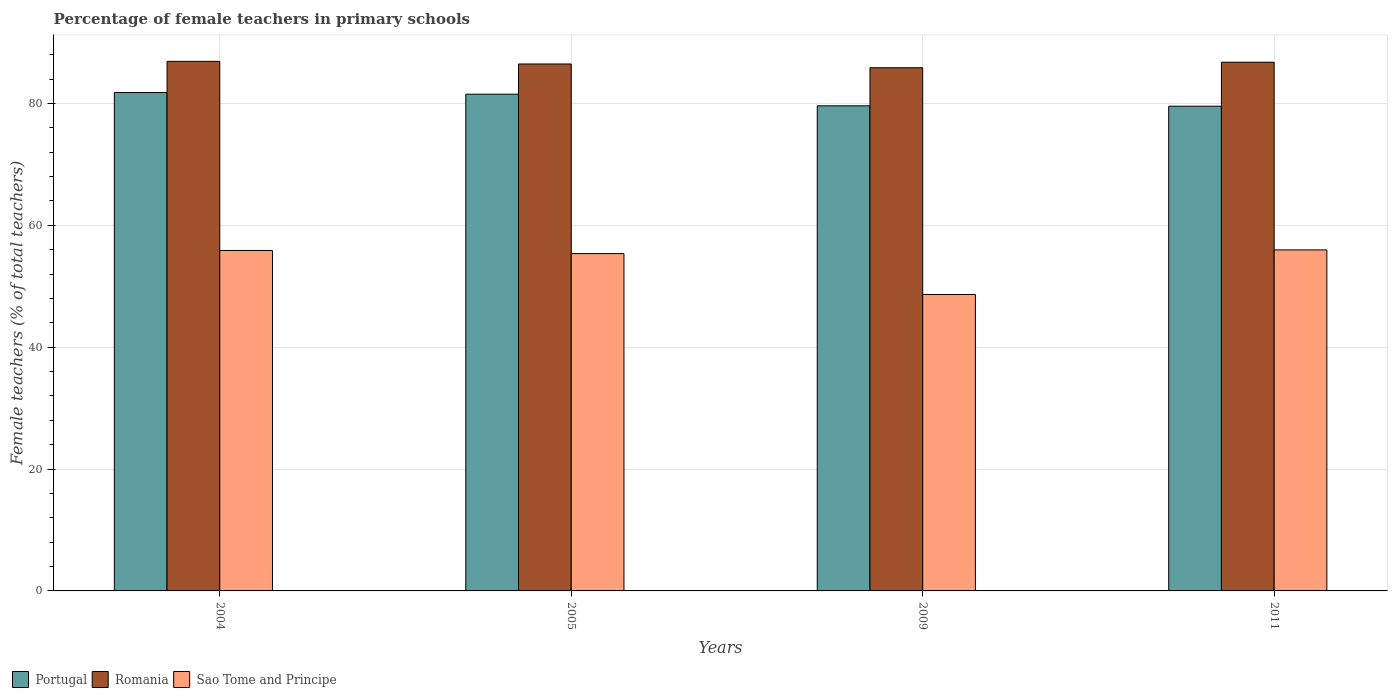Are the number of bars per tick equal to the number of legend labels?
Make the answer very short. Yes. How many bars are there on the 1st tick from the right?
Keep it short and to the point. 3. In how many cases, is the number of bars for a given year not equal to the number of legend labels?
Give a very brief answer. 0. What is the percentage of female teachers in Portugal in 2009?
Provide a succinct answer. 79.6. Across all years, what is the maximum percentage of female teachers in Romania?
Your answer should be very brief. 86.9. Across all years, what is the minimum percentage of female teachers in Romania?
Make the answer very short. 85.85. In which year was the percentage of female teachers in Romania maximum?
Your answer should be compact. 2004. What is the total percentage of female teachers in Portugal in the graph?
Keep it short and to the point. 322.45. What is the difference between the percentage of female teachers in Romania in 2005 and that in 2009?
Provide a short and direct response. 0.62. What is the difference between the percentage of female teachers in Romania in 2009 and the percentage of female teachers in Portugal in 2004?
Keep it short and to the point. 4.06. What is the average percentage of female teachers in Portugal per year?
Make the answer very short. 80.61. In the year 2005, what is the difference between the percentage of female teachers in Sao Tome and Principe and percentage of female teachers in Romania?
Provide a short and direct response. -31.12. What is the ratio of the percentage of female teachers in Romania in 2005 to that in 2009?
Make the answer very short. 1.01. Is the difference between the percentage of female teachers in Sao Tome and Principe in 2004 and 2005 greater than the difference between the percentage of female teachers in Romania in 2004 and 2005?
Provide a short and direct response. Yes. What is the difference between the highest and the second highest percentage of female teachers in Portugal?
Keep it short and to the point. 0.27. What is the difference between the highest and the lowest percentage of female teachers in Sao Tome and Principe?
Keep it short and to the point. 7.31. In how many years, is the percentage of female teachers in Romania greater than the average percentage of female teachers in Romania taken over all years?
Provide a succinct answer. 2. Is the sum of the percentage of female teachers in Sao Tome and Principe in 2004 and 2005 greater than the maximum percentage of female teachers in Portugal across all years?
Offer a terse response. Yes. Is it the case that in every year, the sum of the percentage of female teachers in Portugal and percentage of female teachers in Romania is greater than the percentage of female teachers in Sao Tome and Principe?
Give a very brief answer. Yes. How many years are there in the graph?
Your response must be concise. 4. What is the difference between two consecutive major ticks on the Y-axis?
Your answer should be very brief. 20. Does the graph contain grids?
Make the answer very short. Yes. How many legend labels are there?
Ensure brevity in your answer.  3. What is the title of the graph?
Your response must be concise. Percentage of female teachers in primary schools. Does "Tanzania" appear as one of the legend labels in the graph?
Your response must be concise. No. What is the label or title of the Y-axis?
Provide a short and direct response. Female teachers (% of total teachers). What is the Female teachers (% of total teachers) of Portugal in 2004?
Offer a terse response. 81.79. What is the Female teachers (% of total teachers) of Romania in 2004?
Offer a terse response. 86.9. What is the Female teachers (% of total teachers) of Sao Tome and Principe in 2004?
Provide a succinct answer. 55.87. What is the Female teachers (% of total teachers) of Portugal in 2005?
Keep it short and to the point. 81.52. What is the Female teachers (% of total teachers) in Romania in 2005?
Your response must be concise. 86.47. What is the Female teachers (% of total teachers) in Sao Tome and Principe in 2005?
Provide a succinct answer. 55.35. What is the Female teachers (% of total teachers) of Portugal in 2009?
Offer a very short reply. 79.6. What is the Female teachers (% of total teachers) of Romania in 2009?
Offer a very short reply. 85.85. What is the Female teachers (% of total teachers) of Sao Tome and Principe in 2009?
Provide a succinct answer. 48.64. What is the Female teachers (% of total teachers) of Portugal in 2011?
Your answer should be compact. 79.54. What is the Female teachers (% of total teachers) in Romania in 2011?
Your response must be concise. 86.76. What is the Female teachers (% of total teachers) of Sao Tome and Principe in 2011?
Provide a succinct answer. 55.96. Across all years, what is the maximum Female teachers (% of total teachers) of Portugal?
Give a very brief answer. 81.79. Across all years, what is the maximum Female teachers (% of total teachers) in Romania?
Keep it short and to the point. 86.9. Across all years, what is the maximum Female teachers (% of total teachers) in Sao Tome and Principe?
Give a very brief answer. 55.96. Across all years, what is the minimum Female teachers (% of total teachers) of Portugal?
Your answer should be compact. 79.54. Across all years, what is the minimum Female teachers (% of total teachers) in Romania?
Provide a short and direct response. 85.85. Across all years, what is the minimum Female teachers (% of total teachers) of Sao Tome and Principe?
Offer a very short reply. 48.64. What is the total Female teachers (% of total teachers) of Portugal in the graph?
Provide a short and direct response. 322.45. What is the total Female teachers (% of total teachers) in Romania in the graph?
Offer a terse response. 345.99. What is the total Female teachers (% of total teachers) of Sao Tome and Principe in the graph?
Your response must be concise. 215.82. What is the difference between the Female teachers (% of total teachers) of Portugal in 2004 and that in 2005?
Give a very brief answer. 0.27. What is the difference between the Female teachers (% of total teachers) in Romania in 2004 and that in 2005?
Make the answer very short. 0.43. What is the difference between the Female teachers (% of total teachers) of Sao Tome and Principe in 2004 and that in 2005?
Your response must be concise. 0.51. What is the difference between the Female teachers (% of total teachers) of Portugal in 2004 and that in 2009?
Keep it short and to the point. 2.18. What is the difference between the Female teachers (% of total teachers) of Romania in 2004 and that in 2009?
Ensure brevity in your answer.  1.05. What is the difference between the Female teachers (% of total teachers) in Sao Tome and Principe in 2004 and that in 2009?
Make the answer very short. 7.22. What is the difference between the Female teachers (% of total teachers) of Portugal in 2004 and that in 2011?
Offer a terse response. 2.25. What is the difference between the Female teachers (% of total teachers) of Romania in 2004 and that in 2011?
Your answer should be compact. 0.14. What is the difference between the Female teachers (% of total teachers) in Sao Tome and Principe in 2004 and that in 2011?
Provide a succinct answer. -0.09. What is the difference between the Female teachers (% of total teachers) in Portugal in 2005 and that in 2009?
Provide a succinct answer. 1.91. What is the difference between the Female teachers (% of total teachers) in Romania in 2005 and that in 2009?
Your answer should be very brief. 0.62. What is the difference between the Female teachers (% of total teachers) in Sao Tome and Principe in 2005 and that in 2009?
Offer a terse response. 6.71. What is the difference between the Female teachers (% of total teachers) of Portugal in 2005 and that in 2011?
Your answer should be compact. 1.98. What is the difference between the Female teachers (% of total teachers) of Romania in 2005 and that in 2011?
Your answer should be very brief. -0.29. What is the difference between the Female teachers (% of total teachers) in Sao Tome and Principe in 2005 and that in 2011?
Provide a short and direct response. -0.61. What is the difference between the Female teachers (% of total teachers) of Portugal in 2009 and that in 2011?
Your answer should be very brief. 0.06. What is the difference between the Female teachers (% of total teachers) of Romania in 2009 and that in 2011?
Ensure brevity in your answer.  -0.91. What is the difference between the Female teachers (% of total teachers) in Sao Tome and Principe in 2009 and that in 2011?
Keep it short and to the point. -7.32. What is the difference between the Female teachers (% of total teachers) in Portugal in 2004 and the Female teachers (% of total teachers) in Romania in 2005?
Provide a succinct answer. -4.68. What is the difference between the Female teachers (% of total teachers) in Portugal in 2004 and the Female teachers (% of total teachers) in Sao Tome and Principe in 2005?
Keep it short and to the point. 26.44. What is the difference between the Female teachers (% of total teachers) of Romania in 2004 and the Female teachers (% of total teachers) of Sao Tome and Principe in 2005?
Ensure brevity in your answer.  31.55. What is the difference between the Female teachers (% of total teachers) in Portugal in 2004 and the Female teachers (% of total teachers) in Romania in 2009?
Ensure brevity in your answer.  -4.06. What is the difference between the Female teachers (% of total teachers) in Portugal in 2004 and the Female teachers (% of total teachers) in Sao Tome and Principe in 2009?
Ensure brevity in your answer.  33.14. What is the difference between the Female teachers (% of total teachers) in Romania in 2004 and the Female teachers (% of total teachers) in Sao Tome and Principe in 2009?
Your response must be concise. 38.26. What is the difference between the Female teachers (% of total teachers) of Portugal in 2004 and the Female teachers (% of total teachers) of Romania in 2011?
Provide a succinct answer. -4.97. What is the difference between the Female teachers (% of total teachers) in Portugal in 2004 and the Female teachers (% of total teachers) in Sao Tome and Principe in 2011?
Your response must be concise. 25.83. What is the difference between the Female teachers (% of total teachers) in Romania in 2004 and the Female teachers (% of total teachers) in Sao Tome and Principe in 2011?
Your answer should be very brief. 30.94. What is the difference between the Female teachers (% of total teachers) in Portugal in 2005 and the Female teachers (% of total teachers) in Romania in 2009?
Your answer should be very brief. -4.34. What is the difference between the Female teachers (% of total teachers) in Portugal in 2005 and the Female teachers (% of total teachers) in Sao Tome and Principe in 2009?
Make the answer very short. 32.87. What is the difference between the Female teachers (% of total teachers) in Romania in 2005 and the Female teachers (% of total teachers) in Sao Tome and Principe in 2009?
Ensure brevity in your answer.  37.83. What is the difference between the Female teachers (% of total teachers) in Portugal in 2005 and the Female teachers (% of total teachers) in Romania in 2011?
Keep it short and to the point. -5.25. What is the difference between the Female teachers (% of total teachers) in Portugal in 2005 and the Female teachers (% of total teachers) in Sao Tome and Principe in 2011?
Make the answer very short. 25.56. What is the difference between the Female teachers (% of total teachers) in Romania in 2005 and the Female teachers (% of total teachers) in Sao Tome and Principe in 2011?
Offer a very short reply. 30.51. What is the difference between the Female teachers (% of total teachers) of Portugal in 2009 and the Female teachers (% of total teachers) of Romania in 2011?
Provide a short and direct response. -7.16. What is the difference between the Female teachers (% of total teachers) in Portugal in 2009 and the Female teachers (% of total teachers) in Sao Tome and Principe in 2011?
Your answer should be compact. 23.64. What is the difference between the Female teachers (% of total teachers) of Romania in 2009 and the Female teachers (% of total teachers) of Sao Tome and Principe in 2011?
Keep it short and to the point. 29.89. What is the average Female teachers (% of total teachers) in Portugal per year?
Provide a short and direct response. 80.61. What is the average Female teachers (% of total teachers) of Romania per year?
Your answer should be compact. 86.5. What is the average Female teachers (% of total teachers) in Sao Tome and Principe per year?
Your answer should be compact. 53.96. In the year 2004, what is the difference between the Female teachers (% of total teachers) of Portugal and Female teachers (% of total teachers) of Romania?
Your answer should be compact. -5.11. In the year 2004, what is the difference between the Female teachers (% of total teachers) in Portugal and Female teachers (% of total teachers) in Sao Tome and Principe?
Provide a short and direct response. 25.92. In the year 2004, what is the difference between the Female teachers (% of total teachers) in Romania and Female teachers (% of total teachers) in Sao Tome and Principe?
Offer a terse response. 31.04. In the year 2005, what is the difference between the Female teachers (% of total teachers) in Portugal and Female teachers (% of total teachers) in Romania?
Your answer should be compact. -4.96. In the year 2005, what is the difference between the Female teachers (% of total teachers) of Portugal and Female teachers (% of total teachers) of Sao Tome and Principe?
Give a very brief answer. 26.16. In the year 2005, what is the difference between the Female teachers (% of total teachers) of Romania and Female teachers (% of total teachers) of Sao Tome and Principe?
Offer a terse response. 31.12. In the year 2009, what is the difference between the Female teachers (% of total teachers) in Portugal and Female teachers (% of total teachers) in Romania?
Ensure brevity in your answer.  -6.25. In the year 2009, what is the difference between the Female teachers (% of total teachers) of Portugal and Female teachers (% of total teachers) of Sao Tome and Principe?
Provide a succinct answer. 30.96. In the year 2009, what is the difference between the Female teachers (% of total teachers) in Romania and Female teachers (% of total teachers) in Sao Tome and Principe?
Your answer should be compact. 37.21. In the year 2011, what is the difference between the Female teachers (% of total teachers) in Portugal and Female teachers (% of total teachers) in Romania?
Keep it short and to the point. -7.22. In the year 2011, what is the difference between the Female teachers (% of total teachers) of Portugal and Female teachers (% of total teachers) of Sao Tome and Principe?
Provide a succinct answer. 23.58. In the year 2011, what is the difference between the Female teachers (% of total teachers) in Romania and Female teachers (% of total teachers) in Sao Tome and Principe?
Your answer should be very brief. 30.8. What is the ratio of the Female teachers (% of total teachers) in Portugal in 2004 to that in 2005?
Make the answer very short. 1. What is the ratio of the Female teachers (% of total teachers) of Romania in 2004 to that in 2005?
Give a very brief answer. 1. What is the ratio of the Female teachers (% of total teachers) of Sao Tome and Principe in 2004 to that in 2005?
Offer a terse response. 1.01. What is the ratio of the Female teachers (% of total teachers) of Portugal in 2004 to that in 2009?
Provide a short and direct response. 1.03. What is the ratio of the Female teachers (% of total teachers) of Romania in 2004 to that in 2009?
Offer a terse response. 1.01. What is the ratio of the Female teachers (% of total teachers) in Sao Tome and Principe in 2004 to that in 2009?
Make the answer very short. 1.15. What is the ratio of the Female teachers (% of total teachers) in Portugal in 2004 to that in 2011?
Make the answer very short. 1.03. What is the ratio of the Female teachers (% of total teachers) in Sao Tome and Principe in 2004 to that in 2011?
Ensure brevity in your answer.  1. What is the ratio of the Female teachers (% of total teachers) in Portugal in 2005 to that in 2009?
Offer a terse response. 1.02. What is the ratio of the Female teachers (% of total teachers) of Sao Tome and Principe in 2005 to that in 2009?
Your response must be concise. 1.14. What is the ratio of the Female teachers (% of total teachers) of Portugal in 2005 to that in 2011?
Your answer should be very brief. 1.02. What is the ratio of the Female teachers (% of total teachers) of Sao Tome and Principe in 2005 to that in 2011?
Make the answer very short. 0.99. What is the ratio of the Female teachers (% of total teachers) in Romania in 2009 to that in 2011?
Your answer should be compact. 0.99. What is the ratio of the Female teachers (% of total teachers) in Sao Tome and Principe in 2009 to that in 2011?
Provide a short and direct response. 0.87. What is the difference between the highest and the second highest Female teachers (% of total teachers) in Portugal?
Your answer should be compact. 0.27. What is the difference between the highest and the second highest Female teachers (% of total teachers) in Romania?
Your response must be concise. 0.14. What is the difference between the highest and the second highest Female teachers (% of total teachers) in Sao Tome and Principe?
Provide a short and direct response. 0.09. What is the difference between the highest and the lowest Female teachers (% of total teachers) in Portugal?
Offer a very short reply. 2.25. What is the difference between the highest and the lowest Female teachers (% of total teachers) in Romania?
Your response must be concise. 1.05. What is the difference between the highest and the lowest Female teachers (% of total teachers) in Sao Tome and Principe?
Offer a terse response. 7.32. 